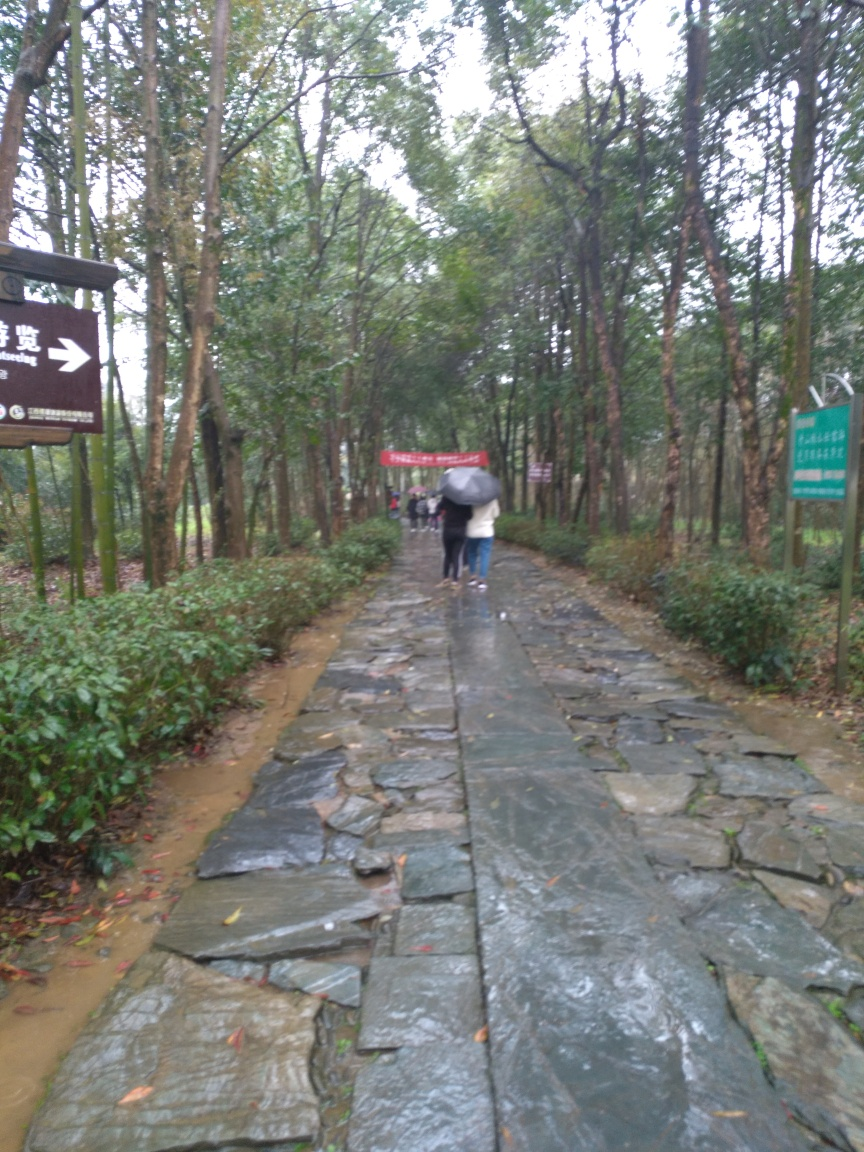Are there any notable features about the pathway itself? The pathway is constructed of irregularly shaped stone slabs, which add a rustic charm and can be a characteristic feature of traditional park pathways. The path appears to be well-used, as evidenced by the wear patterns on the stones, and it may require careful walking due to its uneven surface. Does the pathway indicate any cultural or historical significance? While specific cultural or historical information cannot be accurately determined from the image alone, the design of the pathway, with its natural stone and surrounded by greenery, hints at a design that is in harmony with nature and could be reflective of the local landscape architecture traditions or historical preferences. 